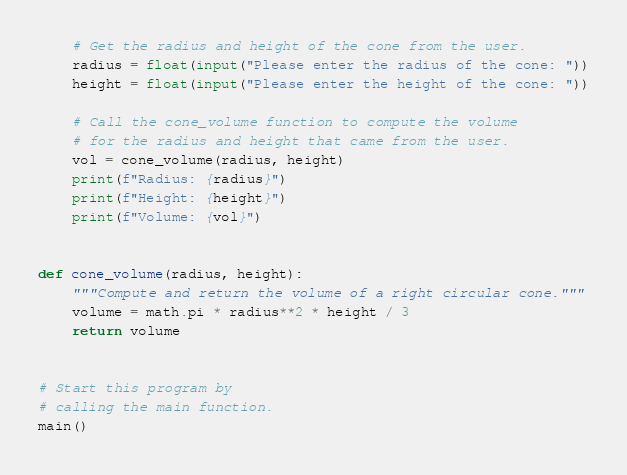Convert code to text. <code><loc_0><loc_0><loc_500><loc_500><_Python_>    # Get the radius and height of the cone from the user.
    radius = float(input("Please enter the radius of the cone: "))
    height = float(input("Please enter the height of the cone: "))

    # Call the cone_volume function to compute the volume
    # for the radius and height that came from the user.
    vol = cone_volume(radius, height)
    print(f"Radius: {radius}")
    print(f"Height: {height}")
    print(f"Volume: {vol}")


def cone_volume(radius, height):
    """Compute and return the volume of a right circular cone."""
    volume = math.pi * radius**2 * height / 3
    return volume


# Start this program by
# calling the main function.
main()</code> 